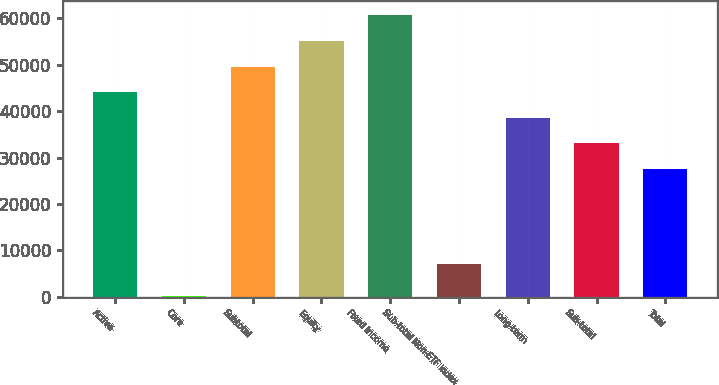Convert chart to OTSL. <chart><loc_0><loc_0><loc_500><loc_500><bar_chart><fcel>Active<fcel>Core<fcel>Subtotal<fcel>Equity<fcel>Fixed Income<fcel>Sub-total Non-ETF Index<fcel>Long-term<fcel>Sub-total<fcel>Total<nl><fcel>44098.2<fcel>179<fcel>49626.6<fcel>55155<fcel>60683.4<fcel>7061<fcel>38569.8<fcel>33041.4<fcel>27513<nl></chart> 